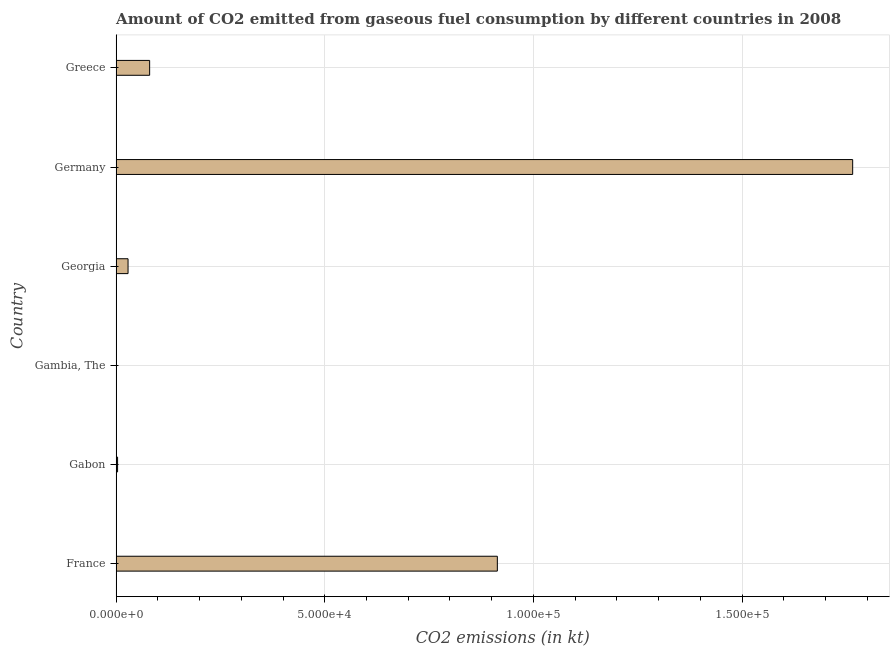Does the graph contain any zero values?
Provide a succinct answer. No. What is the title of the graph?
Your answer should be very brief. Amount of CO2 emitted from gaseous fuel consumption by different countries in 2008. What is the label or title of the X-axis?
Your answer should be very brief. CO2 emissions (in kt). What is the co2 emissions from gaseous fuel consumption in France?
Your response must be concise. 9.13e+04. Across all countries, what is the maximum co2 emissions from gaseous fuel consumption?
Ensure brevity in your answer.  1.76e+05. Across all countries, what is the minimum co2 emissions from gaseous fuel consumption?
Your answer should be compact. 3.67. In which country was the co2 emissions from gaseous fuel consumption minimum?
Your answer should be very brief. Gambia, The. What is the sum of the co2 emissions from gaseous fuel consumption?
Your response must be concise. 2.79e+05. What is the difference between the co2 emissions from gaseous fuel consumption in France and Georgia?
Make the answer very short. 8.85e+04. What is the average co2 emissions from gaseous fuel consumption per country?
Your response must be concise. 4.65e+04. What is the median co2 emissions from gaseous fuel consumption?
Provide a succinct answer. 5443.66. What is the ratio of the co2 emissions from gaseous fuel consumption in Gambia, The to that in Greece?
Offer a terse response. 0. Is the co2 emissions from gaseous fuel consumption in Gambia, The less than that in Greece?
Provide a short and direct response. Yes. Is the difference between the co2 emissions from gaseous fuel consumption in France and Georgia greater than the difference between any two countries?
Keep it short and to the point. No. What is the difference between the highest and the second highest co2 emissions from gaseous fuel consumption?
Offer a very short reply. 8.51e+04. Is the sum of the co2 emissions from gaseous fuel consumption in Georgia and Greece greater than the maximum co2 emissions from gaseous fuel consumption across all countries?
Your response must be concise. No. What is the difference between the highest and the lowest co2 emissions from gaseous fuel consumption?
Provide a short and direct response. 1.76e+05. How many bars are there?
Offer a very short reply. 6. How many countries are there in the graph?
Keep it short and to the point. 6. What is the difference between two consecutive major ticks on the X-axis?
Offer a very short reply. 5.00e+04. What is the CO2 emissions (in kt) of France?
Give a very brief answer. 9.13e+04. What is the CO2 emissions (in kt) of Gabon?
Offer a terse response. 348.37. What is the CO2 emissions (in kt) of Gambia, The?
Give a very brief answer. 3.67. What is the CO2 emissions (in kt) of Georgia?
Keep it short and to the point. 2856.59. What is the CO2 emissions (in kt) in Germany?
Your answer should be compact. 1.76e+05. What is the CO2 emissions (in kt) in Greece?
Offer a very short reply. 8030.73. What is the difference between the CO2 emissions (in kt) in France and Gabon?
Make the answer very short. 9.10e+04. What is the difference between the CO2 emissions (in kt) in France and Gambia, The?
Your answer should be compact. 9.13e+04. What is the difference between the CO2 emissions (in kt) in France and Georgia?
Offer a very short reply. 8.85e+04. What is the difference between the CO2 emissions (in kt) in France and Germany?
Give a very brief answer. -8.51e+04. What is the difference between the CO2 emissions (in kt) in France and Greece?
Ensure brevity in your answer.  8.33e+04. What is the difference between the CO2 emissions (in kt) in Gabon and Gambia, The?
Keep it short and to the point. 344.7. What is the difference between the CO2 emissions (in kt) in Gabon and Georgia?
Offer a very short reply. -2508.23. What is the difference between the CO2 emissions (in kt) in Gabon and Germany?
Give a very brief answer. -1.76e+05. What is the difference between the CO2 emissions (in kt) in Gabon and Greece?
Ensure brevity in your answer.  -7682.36. What is the difference between the CO2 emissions (in kt) in Gambia, The and Georgia?
Offer a terse response. -2852.93. What is the difference between the CO2 emissions (in kt) in Gambia, The and Germany?
Your answer should be compact. -1.76e+05. What is the difference between the CO2 emissions (in kt) in Gambia, The and Greece?
Your answer should be compact. -8027.06. What is the difference between the CO2 emissions (in kt) in Georgia and Germany?
Keep it short and to the point. -1.74e+05. What is the difference between the CO2 emissions (in kt) in Georgia and Greece?
Ensure brevity in your answer.  -5174.14. What is the difference between the CO2 emissions (in kt) in Germany and Greece?
Make the answer very short. 1.68e+05. What is the ratio of the CO2 emissions (in kt) in France to that in Gabon?
Offer a very short reply. 262.22. What is the ratio of the CO2 emissions (in kt) in France to that in Gambia, The?
Ensure brevity in your answer.  2.49e+04. What is the ratio of the CO2 emissions (in kt) in France to that in Georgia?
Keep it short and to the point. 31.98. What is the ratio of the CO2 emissions (in kt) in France to that in Germany?
Offer a very short reply. 0.52. What is the ratio of the CO2 emissions (in kt) in France to that in Greece?
Ensure brevity in your answer.  11.38. What is the ratio of the CO2 emissions (in kt) in Gabon to that in Gambia, The?
Your answer should be very brief. 95. What is the ratio of the CO2 emissions (in kt) in Gabon to that in Georgia?
Your answer should be very brief. 0.12. What is the ratio of the CO2 emissions (in kt) in Gabon to that in Germany?
Your answer should be very brief. 0. What is the ratio of the CO2 emissions (in kt) in Gabon to that in Greece?
Give a very brief answer. 0.04. What is the ratio of the CO2 emissions (in kt) in Gambia, The to that in Greece?
Make the answer very short. 0. What is the ratio of the CO2 emissions (in kt) in Georgia to that in Germany?
Your answer should be very brief. 0.02. What is the ratio of the CO2 emissions (in kt) in Georgia to that in Greece?
Make the answer very short. 0.36. What is the ratio of the CO2 emissions (in kt) in Germany to that in Greece?
Provide a short and direct response. 21.98. 